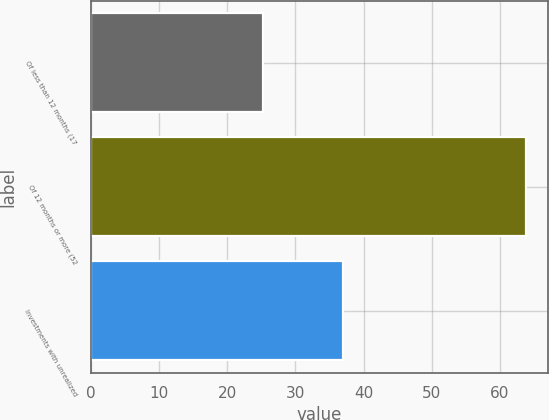Convert chart to OTSL. <chart><loc_0><loc_0><loc_500><loc_500><bar_chart><fcel>Of less than 12 months (17<fcel>Of 12 months or more (52<fcel>Investments with unrealized<nl><fcel>25.3<fcel>63.9<fcel>37<nl></chart> 